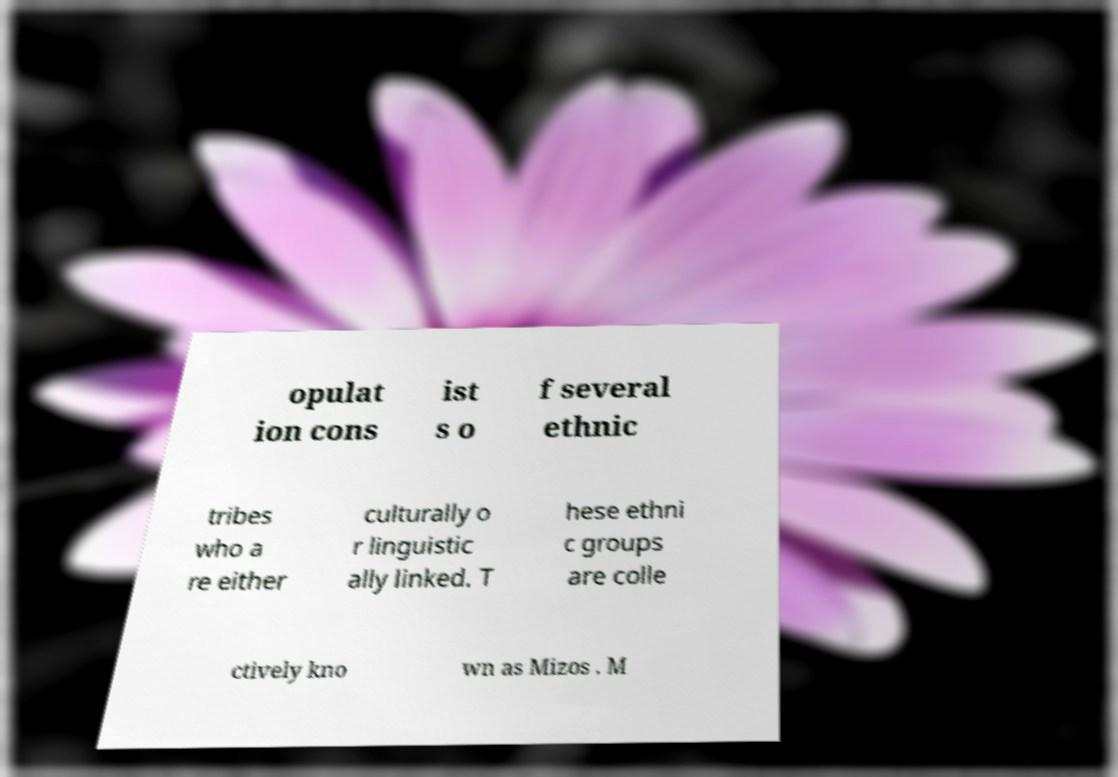Could you assist in decoding the text presented in this image and type it out clearly? opulat ion cons ist s o f several ethnic tribes who a re either culturally o r linguistic ally linked. T hese ethni c groups are colle ctively kno wn as Mizos . M 